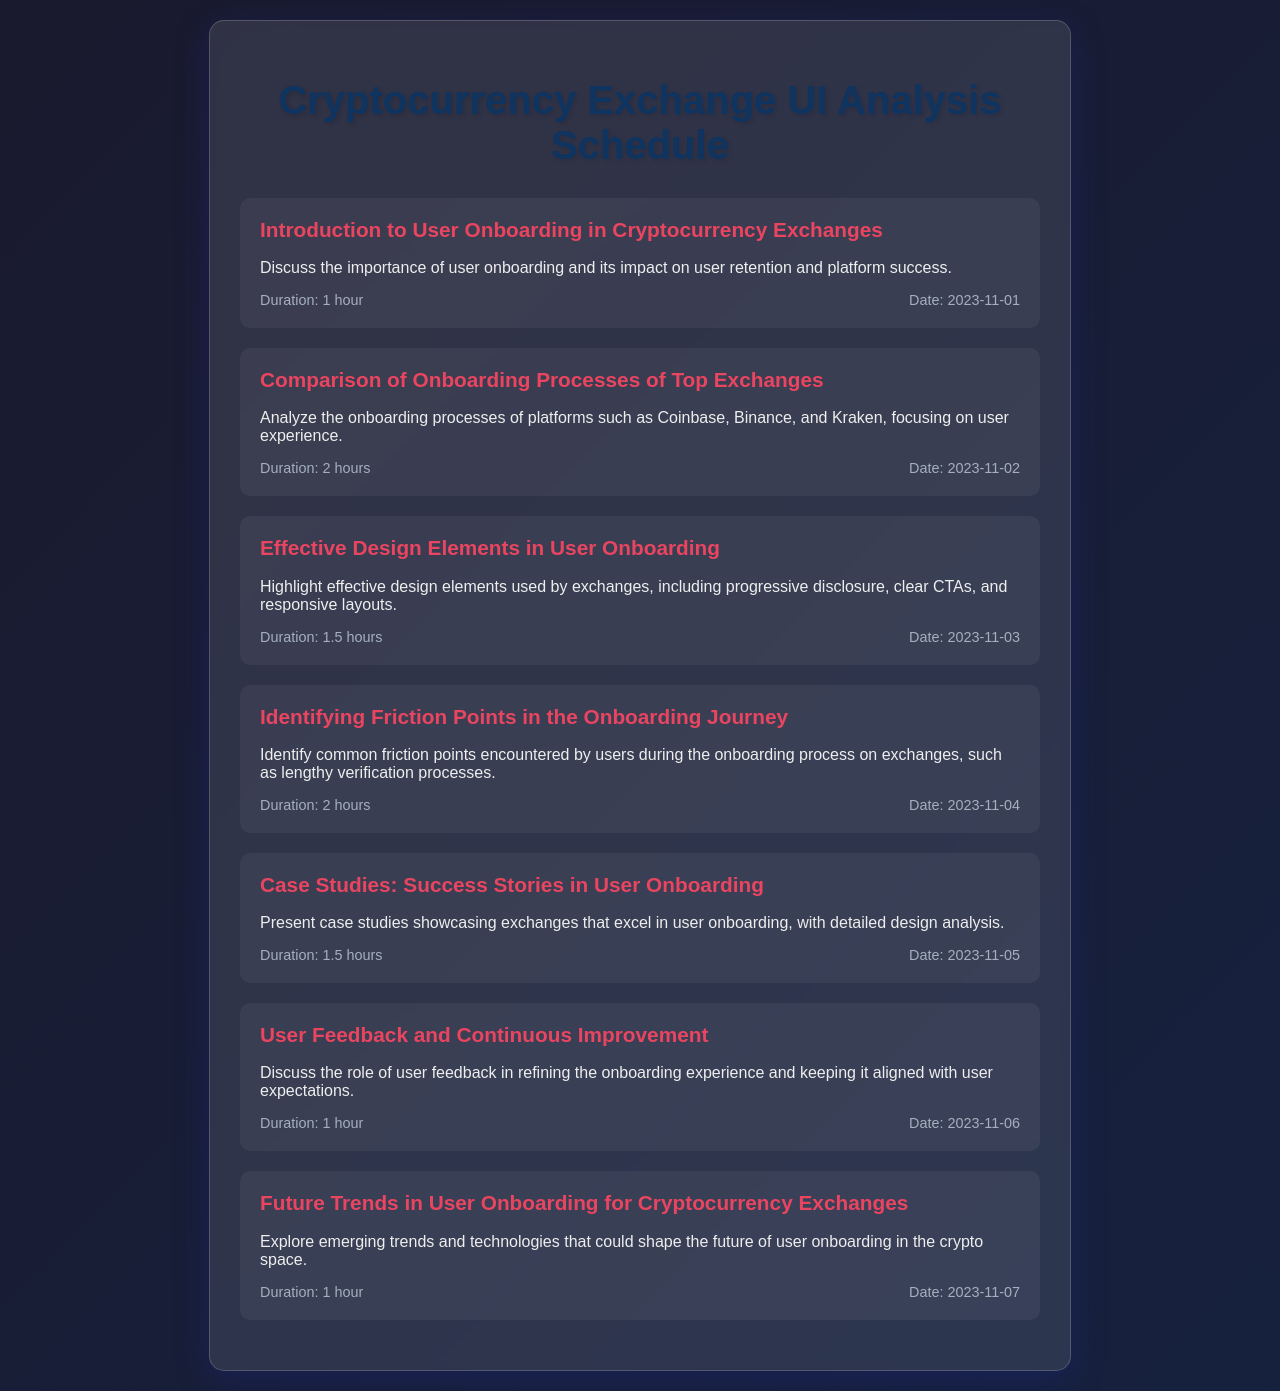What is the first topic discussed? The first topic outlined in the schedule is about the importance of user onboarding and its impact on user retention.
Answer: Introduction to User Onboarding in Cryptocurrency Exchanges What is the duration of the session on identifying friction points? The duration of this session, which focuses on common friction points in onboarding, is specified in the schedule.
Answer: 2 hours On what date is the session about future trends scheduled? The date for the session exploring emerging trends in user onboarding is part of the schedule.
Answer: 2023-11-07 How many hours are focused on effective design elements in user onboarding? The schedule specifies the duration allocated to highlighting effective design elements used by exchanges.
Answer: 1.5 hours What is one design element highlighted in the effective onboarding session? The scheduled session on effective design elements mentions specific features that enhance user experience.
Answer: Progressive disclosure What is the last session in the schedule about? The last session listed in the schedule covers a particular aspect of user onboarding in cryptocurrency exchanges.
Answer: Future Trends in User Onboarding for Cryptocurrency Exchanges Which cryptocurrency exchanges are compared in the onboarding process analysis? The session analyzing onboarding processes lists specific exchanges for comparison.
Answer: Coinbase, Binance, and Kraken What is the purpose of the user feedback session? The schedule describes the role of user feedback in refining onboarding experience.
Answer: Continuous Improvement 